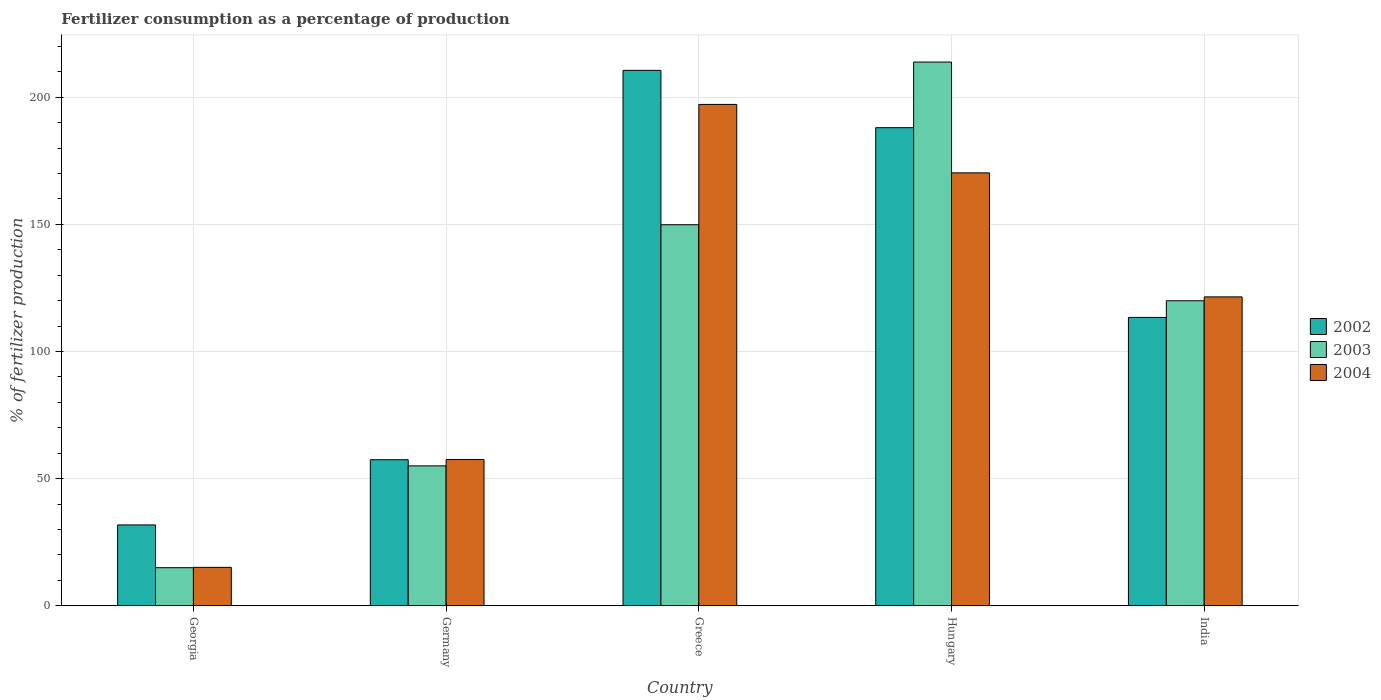How many groups of bars are there?
Make the answer very short. 5. What is the label of the 3rd group of bars from the left?
Keep it short and to the point. Greece. In how many cases, is the number of bars for a given country not equal to the number of legend labels?
Ensure brevity in your answer.  0. What is the percentage of fertilizers consumed in 2002 in Hungary?
Ensure brevity in your answer.  188.03. Across all countries, what is the maximum percentage of fertilizers consumed in 2004?
Provide a succinct answer. 197.18. Across all countries, what is the minimum percentage of fertilizers consumed in 2003?
Your answer should be very brief. 14.99. In which country was the percentage of fertilizers consumed in 2004 maximum?
Make the answer very short. Greece. In which country was the percentage of fertilizers consumed in 2004 minimum?
Your response must be concise. Georgia. What is the total percentage of fertilizers consumed in 2003 in the graph?
Your response must be concise. 553.66. What is the difference between the percentage of fertilizers consumed in 2003 in Georgia and that in India?
Your response must be concise. -104.98. What is the difference between the percentage of fertilizers consumed in 2004 in Georgia and the percentage of fertilizers consumed in 2002 in Greece?
Provide a short and direct response. -195.45. What is the average percentage of fertilizers consumed in 2003 per country?
Keep it short and to the point. 110.73. What is the difference between the percentage of fertilizers consumed of/in 2002 and percentage of fertilizers consumed of/in 2004 in Greece?
Provide a succinct answer. 13.4. In how many countries, is the percentage of fertilizers consumed in 2004 greater than 10 %?
Ensure brevity in your answer.  5. What is the ratio of the percentage of fertilizers consumed in 2004 in Georgia to that in Germany?
Make the answer very short. 0.26. Is the percentage of fertilizers consumed in 2004 in Germany less than that in Greece?
Your answer should be compact. Yes. Is the difference between the percentage of fertilizers consumed in 2002 in Georgia and India greater than the difference between the percentage of fertilizers consumed in 2004 in Georgia and India?
Provide a succinct answer. Yes. What is the difference between the highest and the second highest percentage of fertilizers consumed in 2003?
Your answer should be very brief. 63.98. What is the difference between the highest and the lowest percentage of fertilizers consumed in 2002?
Make the answer very short. 178.77. Is it the case that in every country, the sum of the percentage of fertilizers consumed in 2002 and percentage of fertilizers consumed in 2004 is greater than the percentage of fertilizers consumed in 2003?
Ensure brevity in your answer.  Yes. How many bars are there?
Offer a terse response. 15. How many countries are there in the graph?
Keep it short and to the point. 5. What is the difference between two consecutive major ticks on the Y-axis?
Offer a very short reply. 50. Where does the legend appear in the graph?
Make the answer very short. Center right. How many legend labels are there?
Offer a terse response. 3. How are the legend labels stacked?
Your answer should be very brief. Vertical. What is the title of the graph?
Provide a short and direct response. Fertilizer consumption as a percentage of production. Does "2005" appear as one of the legend labels in the graph?
Your response must be concise. No. What is the label or title of the X-axis?
Give a very brief answer. Country. What is the label or title of the Y-axis?
Give a very brief answer. % of fertilizer production. What is the % of fertilizer production of 2002 in Georgia?
Keep it short and to the point. 31.81. What is the % of fertilizer production of 2003 in Georgia?
Offer a terse response. 14.99. What is the % of fertilizer production in 2004 in Georgia?
Provide a short and direct response. 15.12. What is the % of fertilizer production in 2002 in Germany?
Ensure brevity in your answer.  57.44. What is the % of fertilizer production of 2003 in Germany?
Keep it short and to the point. 55.03. What is the % of fertilizer production in 2004 in Germany?
Provide a short and direct response. 57.52. What is the % of fertilizer production of 2002 in Greece?
Make the answer very short. 210.57. What is the % of fertilizer production in 2003 in Greece?
Provide a short and direct response. 149.85. What is the % of fertilizer production of 2004 in Greece?
Your answer should be very brief. 197.18. What is the % of fertilizer production of 2002 in Hungary?
Provide a short and direct response. 188.03. What is the % of fertilizer production of 2003 in Hungary?
Your answer should be very brief. 213.83. What is the % of fertilizer production of 2004 in Hungary?
Ensure brevity in your answer.  170.26. What is the % of fertilizer production in 2002 in India?
Offer a very short reply. 113.4. What is the % of fertilizer production in 2003 in India?
Offer a terse response. 119.96. What is the % of fertilizer production in 2004 in India?
Give a very brief answer. 121.49. Across all countries, what is the maximum % of fertilizer production in 2002?
Make the answer very short. 210.57. Across all countries, what is the maximum % of fertilizer production in 2003?
Your answer should be compact. 213.83. Across all countries, what is the maximum % of fertilizer production of 2004?
Ensure brevity in your answer.  197.18. Across all countries, what is the minimum % of fertilizer production of 2002?
Offer a terse response. 31.81. Across all countries, what is the minimum % of fertilizer production in 2003?
Keep it short and to the point. 14.99. Across all countries, what is the minimum % of fertilizer production of 2004?
Offer a terse response. 15.12. What is the total % of fertilizer production in 2002 in the graph?
Your answer should be very brief. 601.25. What is the total % of fertilizer production in 2003 in the graph?
Offer a terse response. 553.66. What is the total % of fertilizer production of 2004 in the graph?
Provide a succinct answer. 561.56. What is the difference between the % of fertilizer production of 2002 in Georgia and that in Germany?
Provide a short and direct response. -25.63. What is the difference between the % of fertilizer production of 2003 in Georgia and that in Germany?
Your answer should be very brief. -40.04. What is the difference between the % of fertilizer production in 2004 in Georgia and that in Germany?
Provide a succinct answer. -42.4. What is the difference between the % of fertilizer production of 2002 in Georgia and that in Greece?
Offer a very short reply. -178.77. What is the difference between the % of fertilizer production in 2003 in Georgia and that in Greece?
Give a very brief answer. -134.87. What is the difference between the % of fertilizer production in 2004 in Georgia and that in Greece?
Keep it short and to the point. -182.06. What is the difference between the % of fertilizer production in 2002 in Georgia and that in Hungary?
Give a very brief answer. -156.22. What is the difference between the % of fertilizer production of 2003 in Georgia and that in Hungary?
Offer a very short reply. -198.85. What is the difference between the % of fertilizer production in 2004 in Georgia and that in Hungary?
Your answer should be compact. -155.14. What is the difference between the % of fertilizer production of 2002 in Georgia and that in India?
Give a very brief answer. -81.59. What is the difference between the % of fertilizer production of 2003 in Georgia and that in India?
Give a very brief answer. -104.98. What is the difference between the % of fertilizer production in 2004 in Georgia and that in India?
Make the answer very short. -106.37. What is the difference between the % of fertilizer production in 2002 in Germany and that in Greece?
Provide a short and direct response. -153.13. What is the difference between the % of fertilizer production of 2003 in Germany and that in Greece?
Offer a terse response. -94.83. What is the difference between the % of fertilizer production in 2004 in Germany and that in Greece?
Make the answer very short. -139.65. What is the difference between the % of fertilizer production in 2002 in Germany and that in Hungary?
Give a very brief answer. -130.58. What is the difference between the % of fertilizer production in 2003 in Germany and that in Hungary?
Make the answer very short. -158.81. What is the difference between the % of fertilizer production of 2004 in Germany and that in Hungary?
Ensure brevity in your answer.  -112.73. What is the difference between the % of fertilizer production of 2002 in Germany and that in India?
Your answer should be compact. -55.96. What is the difference between the % of fertilizer production of 2003 in Germany and that in India?
Your response must be concise. -64.94. What is the difference between the % of fertilizer production of 2004 in Germany and that in India?
Make the answer very short. -63.96. What is the difference between the % of fertilizer production in 2002 in Greece and that in Hungary?
Make the answer very short. 22.55. What is the difference between the % of fertilizer production of 2003 in Greece and that in Hungary?
Keep it short and to the point. -63.98. What is the difference between the % of fertilizer production of 2004 in Greece and that in Hungary?
Provide a short and direct response. 26.92. What is the difference between the % of fertilizer production of 2002 in Greece and that in India?
Provide a succinct answer. 97.17. What is the difference between the % of fertilizer production in 2003 in Greece and that in India?
Offer a terse response. 29.89. What is the difference between the % of fertilizer production of 2004 in Greece and that in India?
Your answer should be compact. 75.69. What is the difference between the % of fertilizer production of 2002 in Hungary and that in India?
Your answer should be compact. 74.62. What is the difference between the % of fertilizer production of 2003 in Hungary and that in India?
Your answer should be compact. 93.87. What is the difference between the % of fertilizer production in 2004 in Hungary and that in India?
Your response must be concise. 48.77. What is the difference between the % of fertilizer production in 2002 in Georgia and the % of fertilizer production in 2003 in Germany?
Offer a very short reply. -23.22. What is the difference between the % of fertilizer production of 2002 in Georgia and the % of fertilizer production of 2004 in Germany?
Your answer should be very brief. -25.72. What is the difference between the % of fertilizer production of 2003 in Georgia and the % of fertilizer production of 2004 in Germany?
Your answer should be very brief. -42.54. What is the difference between the % of fertilizer production of 2002 in Georgia and the % of fertilizer production of 2003 in Greece?
Give a very brief answer. -118.05. What is the difference between the % of fertilizer production in 2002 in Georgia and the % of fertilizer production in 2004 in Greece?
Ensure brevity in your answer.  -165.37. What is the difference between the % of fertilizer production in 2003 in Georgia and the % of fertilizer production in 2004 in Greece?
Give a very brief answer. -182.19. What is the difference between the % of fertilizer production of 2002 in Georgia and the % of fertilizer production of 2003 in Hungary?
Give a very brief answer. -182.03. What is the difference between the % of fertilizer production in 2002 in Georgia and the % of fertilizer production in 2004 in Hungary?
Make the answer very short. -138.45. What is the difference between the % of fertilizer production in 2003 in Georgia and the % of fertilizer production in 2004 in Hungary?
Keep it short and to the point. -155.27. What is the difference between the % of fertilizer production in 2002 in Georgia and the % of fertilizer production in 2003 in India?
Ensure brevity in your answer.  -88.15. What is the difference between the % of fertilizer production in 2002 in Georgia and the % of fertilizer production in 2004 in India?
Offer a terse response. -89.68. What is the difference between the % of fertilizer production in 2003 in Georgia and the % of fertilizer production in 2004 in India?
Your answer should be very brief. -106.5. What is the difference between the % of fertilizer production in 2002 in Germany and the % of fertilizer production in 2003 in Greece?
Ensure brevity in your answer.  -92.41. What is the difference between the % of fertilizer production in 2002 in Germany and the % of fertilizer production in 2004 in Greece?
Your response must be concise. -139.73. What is the difference between the % of fertilizer production of 2003 in Germany and the % of fertilizer production of 2004 in Greece?
Offer a terse response. -142.15. What is the difference between the % of fertilizer production of 2002 in Germany and the % of fertilizer production of 2003 in Hungary?
Provide a short and direct response. -156.39. What is the difference between the % of fertilizer production of 2002 in Germany and the % of fertilizer production of 2004 in Hungary?
Offer a terse response. -112.81. What is the difference between the % of fertilizer production in 2003 in Germany and the % of fertilizer production in 2004 in Hungary?
Make the answer very short. -115.23. What is the difference between the % of fertilizer production of 2002 in Germany and the % of fertilizer production of 2003 in India?
Offer a very short reply. -62.52. What is the difference between the % of fertilizer production in 2002 in Germany and the % of fertilizer production in 2004 in India?
Make the answer very short. -64.04. What is the difference between the % of fertilizer production of 2003 in Germany and the % of fertilizer production of 2004 in India?
Offer a terse response. -66.46. What is the difference between the % of fertilizer production of 2002 in Greece and the % of fertilizer production of 2003 in Hungary?
Your response must be concise. -3.26. What is the difference between the % of fertilizer production of 2002 in Greece and the % of fertilizer production of 2004 in Hungary?
Make the answer very short. 40.32. What is the difference between the % of fertilizer production of 2003 in Greece and the % of fertilizer production of 2004 in Hungary?
Provide a succinct answer. -20.4. What is the difference between the % of fertilizer production of 2002 in Greece and the % of fertilizer production of 2003 in India?
Give a very brief answer. 90.61. What is the difference between the % of fertilizer production of 2002 in Greece and the % of fertilizer production of 2004 in India?
Offer a very short reply. 89.09. What is the difference between the % of fertilizer production of 2003 in Greece and the % of fertilizer production of 2004 in India?
Your answer should be compact. 28.37. What is the difference between the % of fertilizer production in 2002 in Hungary and the % of fertilizer production in 2003 in India?
Offer a terse response. 68.06. What is the difference between the % of fertilizer production in 2002 in Hungary and the % of fertilizer production in 2004 in India?
Make the answer very short. 66.54. What is the difference between the % of fertilizer production of 2003 in Hungary and the % of fertilizer production of 2004 in India?
Your response must be concise. 92.35. What is the average % of fertilizer production in 2002 per country?
Ensure brevity in your answer.  120.25. What is the average % of fertilizer production of 2003 per country?
Your response must be concise. 110.73. What is the average % of fertilizer production in 2004 per country?
Offer a very short reply. 112.31. What is the difference between the % of fertilizer production in 2002 and % of fertilizer production in 2003 in Georgia?
Ensure brevity in your answer.  16.82. What is the difference between the % of fertilizer production of 2002 and % of fertilizer production of 2004 in Georgia?
Your answer should be compact. 16.69. What is the difference between the % of fertilizer production in 2003 and % of fertilizer production in 2004 in Georgia?
Give a very brief answer. -0.13. What is the difference between the % of fertilizer production in 2002 and % of fertilizer production in 2003 in Germany?
Your response must be concise. 2.42. What is the difference between the % of fertilizer production of 2002 and % of fertilizer production of 2004 in Germany?
Ensure brevity in your answer.  -0.08. What is the difference between the % of fertilizer production of 2003 and % of fertilizer production of 2004 in Germany?
Keep it short and to the point. -2.5. What is the difference between the % of fertilizer production of 2002 and % of fertilizer production of 2003 in Greece?
Ensure brevity in your answer.  60.72. What is the difference between the % of fertilizer production in 2002 and % of fertilizer production in 2004 in Greece?
Keep it short and to the point. 13.4. What is the difference between the % of fertilizer production in 2003 and % of fertilizer production in 2004 in Greece?
Offer a terse response. -47.32. What is the difference between the % of fertilizer production in 2002 and % of fertilizer production in 2003 in Hungary?
Your answer should be compact. -25.81. What is the difference between the % of fertilizer production of 2002 and % of fertilizer production of 2004 in Hungary?
Offer a terse response. 17.77. What is the difference between the % of fertilizer production of 2003 and % of fertilizer production of 2004 in Hungary?
Offer a terse response. 43.58. What is the difference between the % of fertilizer production of 2002 and % of fertilizer production of 2003 in India?
Make the answer very short. -6.56. What is the difference between the % of fertilizer production of 2002 and % of fertilizer production of 2004 in India?
Give a very brief answer. -8.09. What is the difference between the % of fertilizer production in 2003 and % of fertilizer production in 2004 in India?
Your answer should be compact. -1.53. What is the ratio of the % of fertilizer production of 2002 in Georgia to that in Germany?
Keep it short and to the point. 0.55. What is the ratio of the % of fertilizer production in 2003 in Georgia to that in Germany?
Your answer should be compact. 0.27. What is the ratio of the % of fertilizer production in 2004 in Georgia to that in Germany?
Ensure brevity in your answer.  0.26. What is the ratio of the % of fertilizer production of 2002 in Georgia to that in Greece?
Your response must be concise. 0.15. What is the ratio of the % of fertilizer production in 2004 in Georgia to that in Greece?
Ensure brevity in your answer.  0.08. What is the ratio of the % of fertilizer production of 2002 in Georgia to that in Hungary?
Provide a short and direct response. 0.17. What is the ratio of the % of fertilizer production in 2003 in Georgia to that in Hungary?
Your answer should be compact. 0.07. What is the ratio of the % of fertilizer production in 2004 in Georgia to that in Hungary?
Your answer should be compact. 0.09. What is the ratio of the % of fertilizer production of 2002 in Georgia to that in India?
Your answer should be very brief. 0.28. What is the ratio of the % of fertilizer production in 2003 in Georgia to that in India?
Offer a very short reply. 0.12. What is the ratio of the % of fertilizer production in 2004 in Georgia to that in India?
Give a very brief answer. 0.12. What is the ratio of the % of fertilizer production in 2002 in Germany to that in Greece?
Ensure brevity in your answer.  0.27. What is the ratio of the % of fertilizer production in 2003 in Germany to that in Greece?
Your response must be concise. 0.37. What is the ratio of the % of fertilizer production in 2004 in Germany to that in Greece?
Your answer should be compact. 0.29. What is the ratio of the % of fertilizer production in 2002 in Germany to that in Hungary?
Offer a very short reply. 0.31. What is the ratio of the % of fertilizer production of 2003 in Germany to that in Hungary?
Give a very brief answer. 0.26. What is the ratio of the % of fertilizer production of 2004 in Germany to that in Hungary?
Keep it short and to the point. 0.34. What is the ratio of the % of fertilizer production of 2002 in Germany to that in India?
Make the answer very short. 0.51. What is the ratio of the % of fertilizer production of 2003 in Germany to that in India?
Keep it short and to the point. 0.46. What is the ratio of the % of fertilizer production of 2004 in Germany to that in India?
Offer a terse response. 0.47. What is the ratio of the % of fertilizer production in 2002 in Greece to that in Hungary?
Offer a very short reply. 1.12. What is the ratio of the % of fertilizer production of 2003 in Greece to that in Hungary?
Ensure brevity in your answer.  0.7. What is the ratio of the % of fertilizer production of 2004 in Greece to that in Hungary?
Your answer should be compact. 1.16. What is the ratio of the % of fertilizer production of 2002 in Greece to that in India?
Provide a short and direct response. 1.86. What is the ratio of the % of fertilizer production of 2003 in Greece to that in India?
Give a very brief answer. 1.25. What is the ratio of the % of fertilizer production in 2004 in Greece to that in India?
Your answer should be compact. 1.62. What is the ratio of the % of fertilizer production in 2002 in Hungary to that in India?
Keep it short and to the point. 1.66. What is the ratio of the % of fertilizer production in 2003 in Hungary to that in India?
Provide a short and direct response. 1.78. What is the ratio of the % of fertilizer production in 2004 in Hungary to that in India?
Offer a terse response. 1.4. What is the difference between the highest and the second highest % of fertilizer production of 2002?
Make the answer very short. 22.55. What is the difference between the highest and the second highest % of fertilizer production of 2003?
Provide a short and direct response. 63.98. What is the difference between the highest and the second highest % of fertilizer production of 2004?
Keep it short and to the point. 26.92. What is the difference between the highest and the lowest % of fertilizer production of 2002?
Provide a short and direct response. 178.77. What is the difference between the highest and the lowest % of fertilizer production in 2003?
Your response must be concise. 198.85. What is the difference between the highest and the lowest % of fertilizer production of 2004?
Make the answer very short. 182.06. 